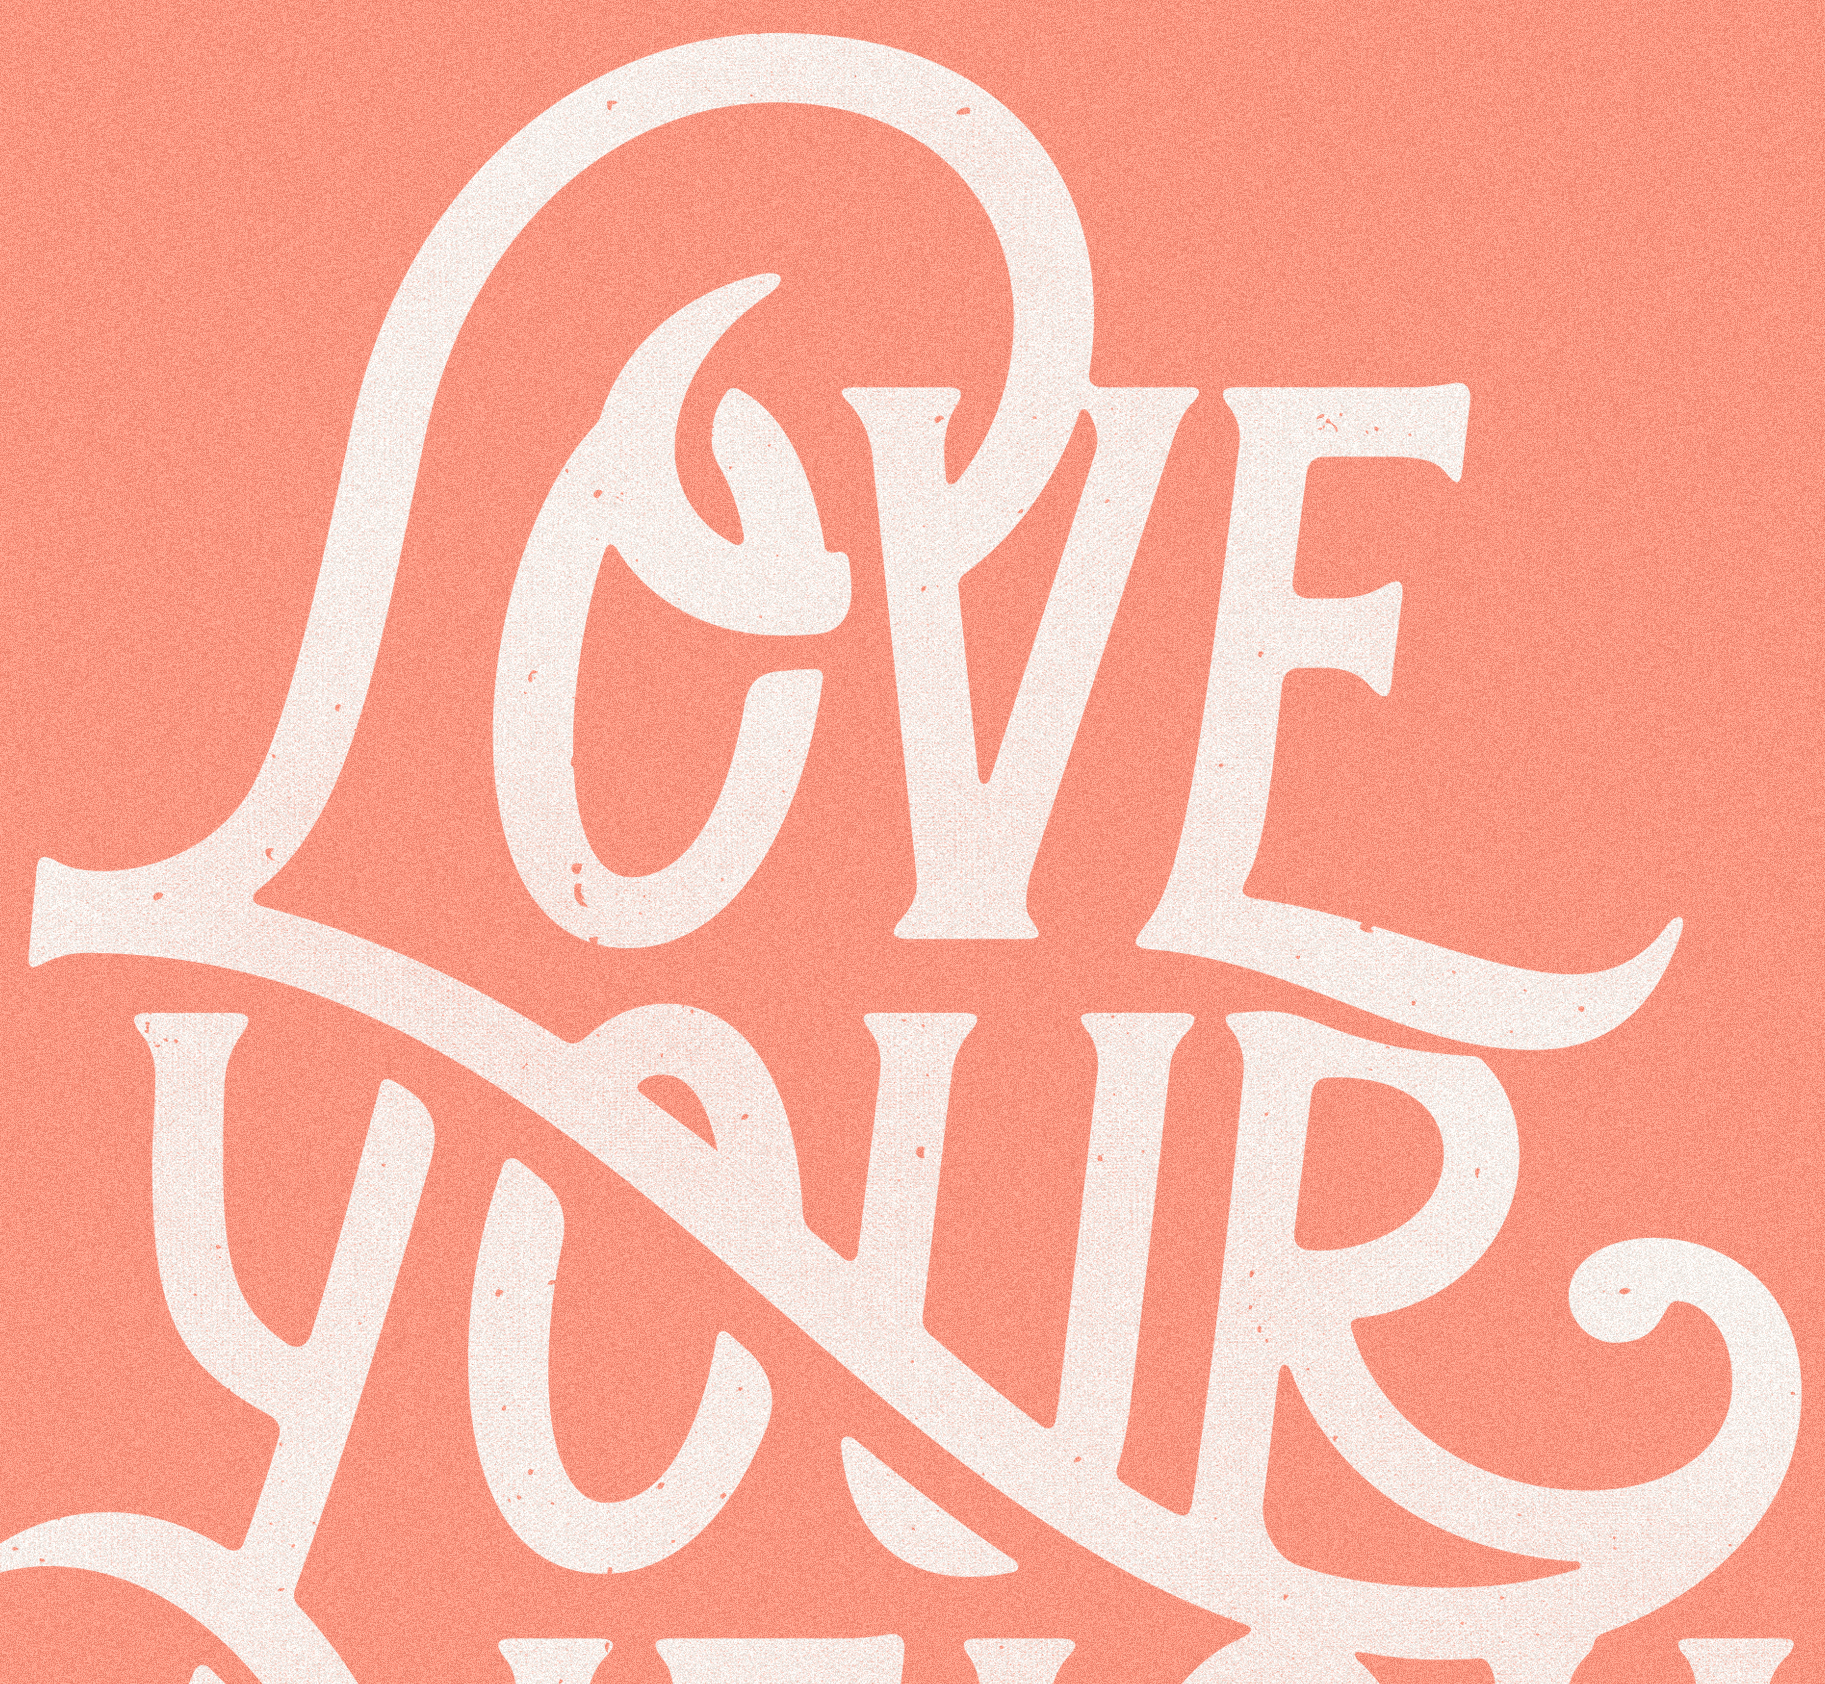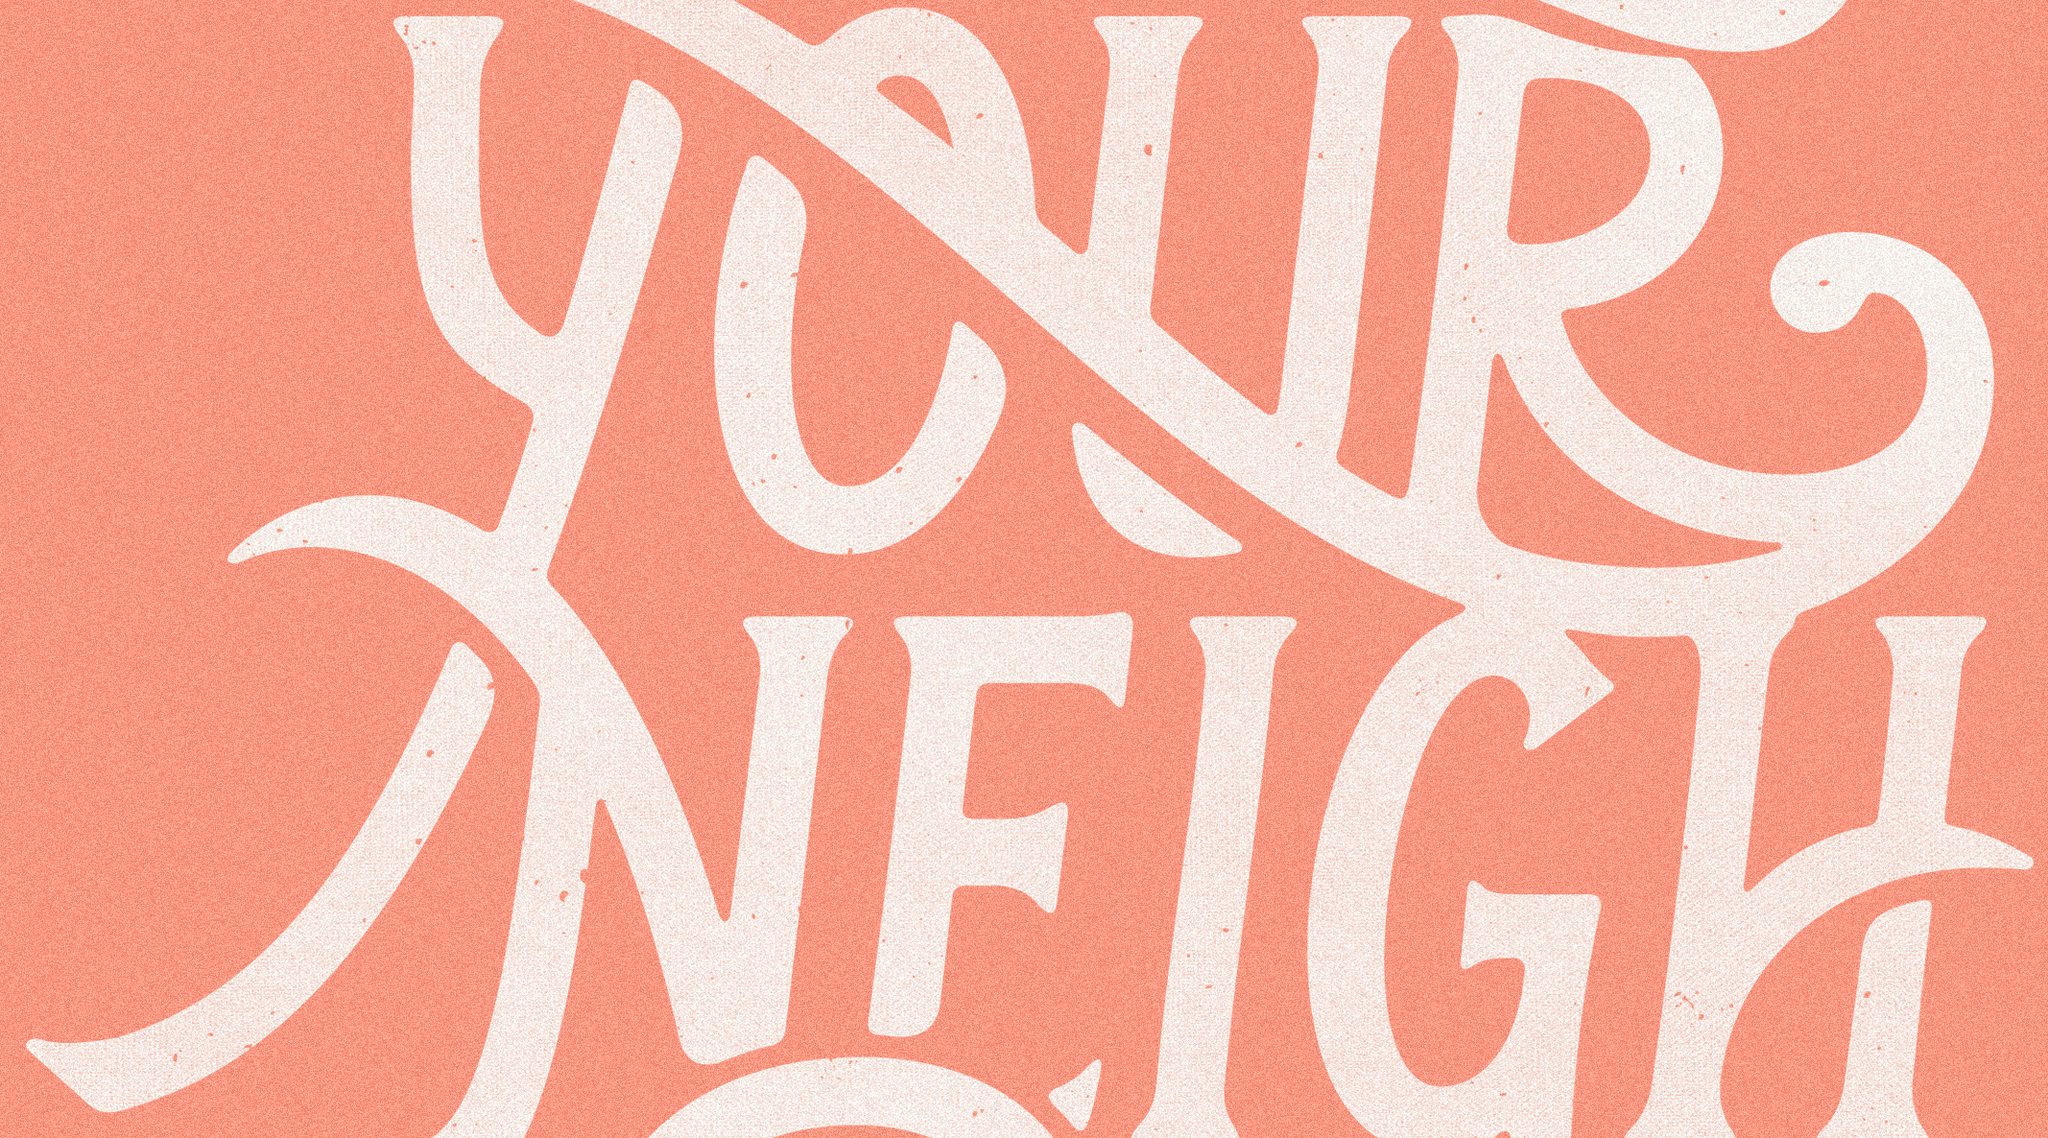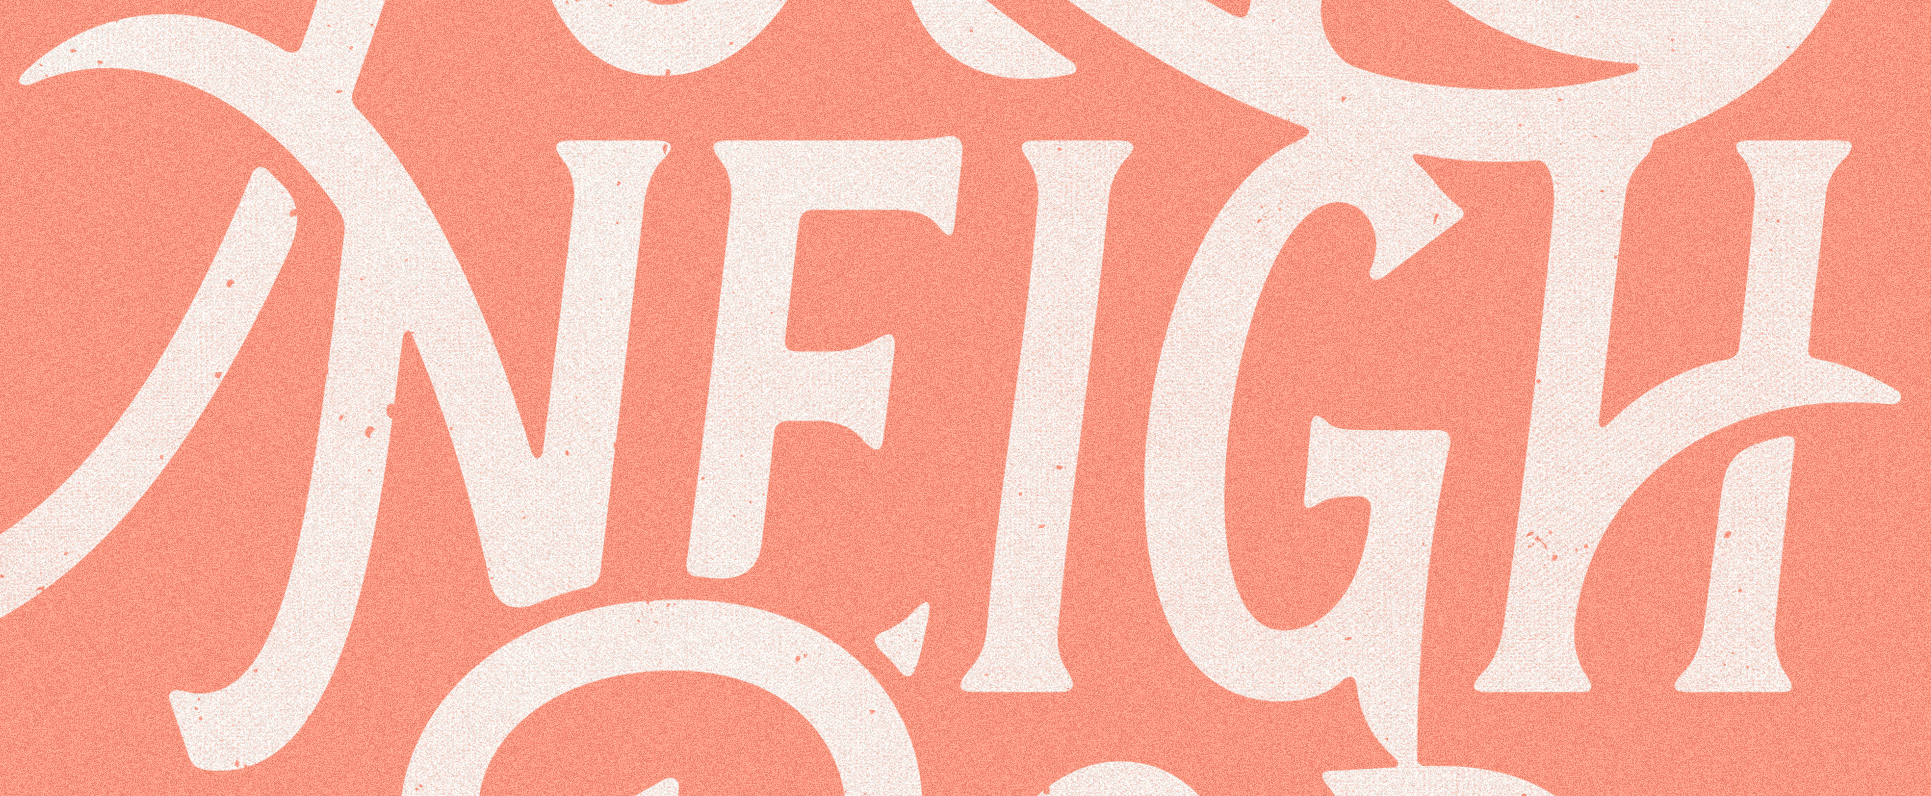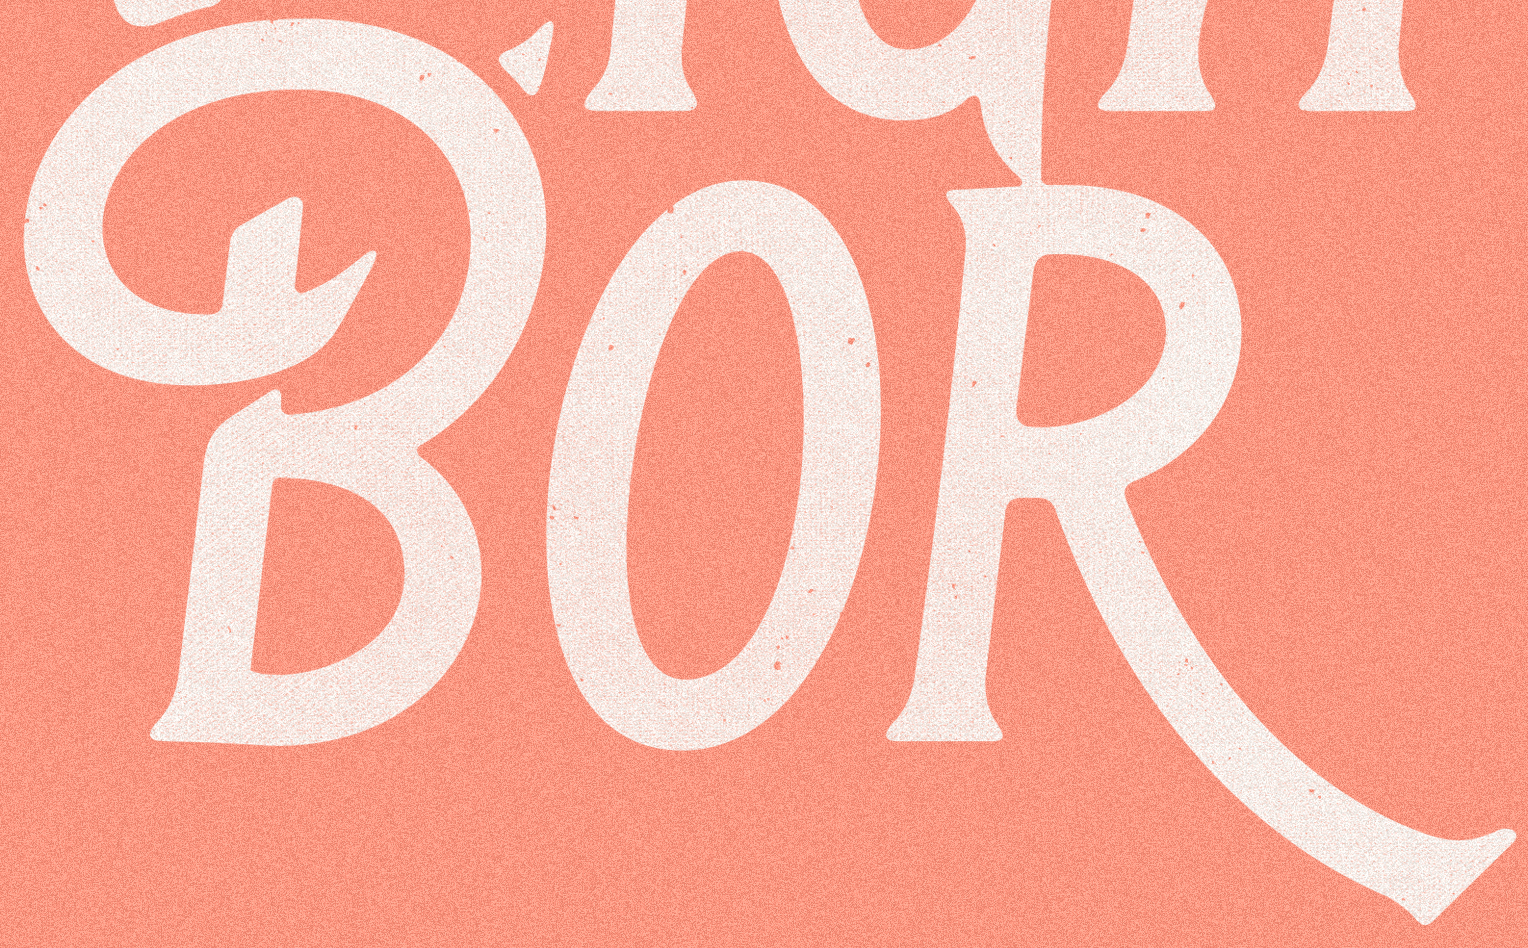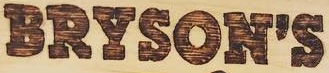What text appears in these images from left to right, separated by a semicolon? LOVE; YOUR; NEIGH; BOR; BRYSON'S 